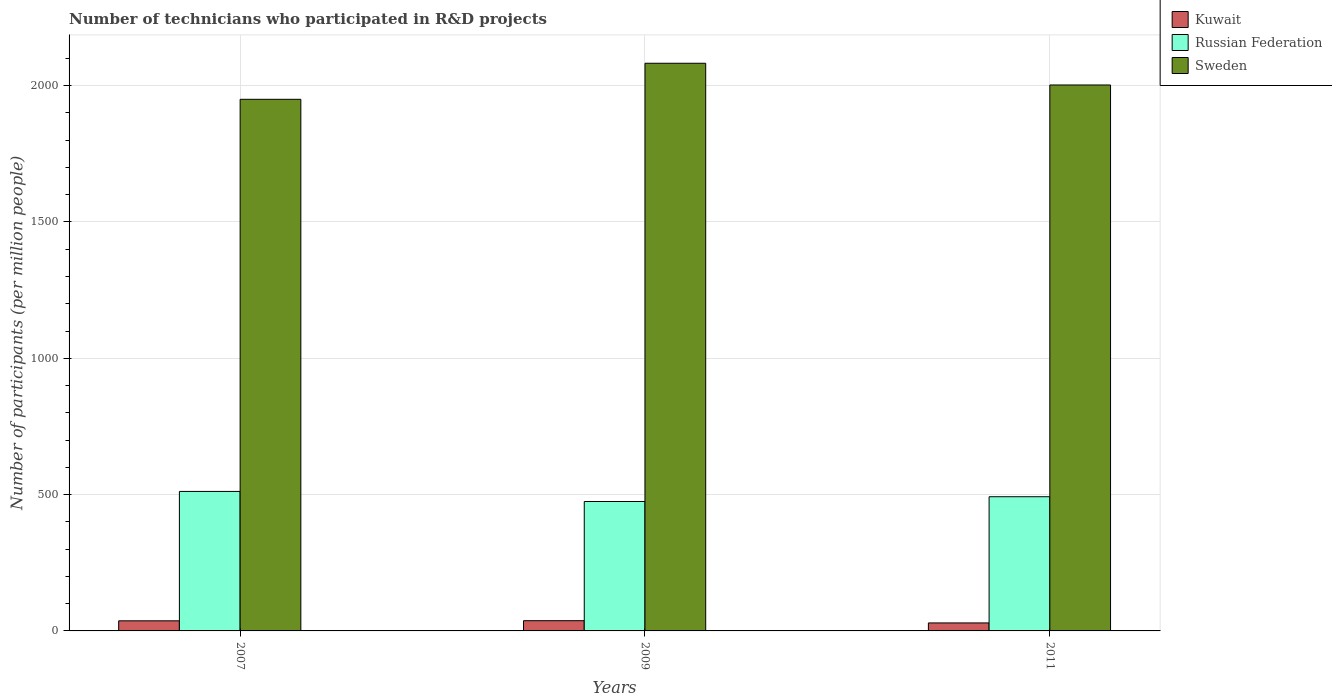How many different coloured bars are there?
Keep it short and to the point. 3. How many groups of bars are there?
Provide a succinct answer. 3. Are the number of bars per tick equal to the number of legend labels?
Ensure brevity in your answer.  Yes. Are the number of bars on each tick of the X-axis equal?
Offer a terse response. Yes. How many bars are there on the 1st tick from the right?
Give a very brief answer. 3. What is the label of the 1st group of bars from the left?
Offer a terse response. 2007. In how many cases, is the number of bars for a given year not equal to the number of legend labels?
Give a very brief answer. 0. What is the number of technicians who participated in R&D projects in Russian Federation in 2007?
Offer a very short reply. 511.64. Across all years, what is the maximum number of technicians who participated in R&D projects in Russian Federation?
Your answer should be very brief. 511.64. Across all years, what is the minimum number of technicians who participated in R&D projects in Kuwait?
Offer a very short reply. 29.33. In which year was the number of technicians who participated in R&D projects in Kuwait maximum?
Offer a terse response. 2009. In which year was the number of technicians who participated in R&D projects in Russian Federation minimum?
Provide a succinct answer. 2009. What is the total number of technicians who participated in R&D projects in Sweden in the graph?
Your answer should be compact. 6034.81. What is the difference between the number of technicians who participated in R&D projects in Kuwait in 2007 and that in 2011?
Offer a very short reply. 7.7. What is the difference between the number of technicians who participated in R&D projects in Russian Federation in 2007 and the number of technicians who participated in R&D projects in Sweden in 2011?
Ensure brevity in your answer.  -1490.93. What is the average number of technicians who participated in R&D projects in Sweden per year?
Your answer should be very brief. 2011.6. In the year 2011, what is the difference between the number of technicians who participated in R&D projects in Russian Federation and number of technicians who participated in R&D projects in Kuwait?
Your answer should be very brief. 462.89. In how many years, is the number of technicians who participated in R&D projects in Russian Federation greater than 1300?
Your response must be concise. 0. What is the ratio of the number of technicians who participated in R&D projects in Sweden in 2007 to that in 2009?
Provide a succinct answer. 0.94. Is the number of technicians who participated in R&D projects in Sweden in 2007 less than that in 2009?
Your answer should be very brief. Yes. What is the difference between the highest and the second highest number of technicians who participated in R&D projects in Sweden?
Your answer should be compact. 79.67. What is the difference between the highest and the lowest number of technicians who participated in R&D projects in Russian Federation?
Provide a short and direct response. 36.87. In how many years, is the number of technicians who participated in R&D projects in Sweden greater than the average number of technicians who participated in R&D projects in Sweden taken over all years?
Provide a succinct answer. 1. Is the sum of the number of technicians who participated in R&D projects in Sweden in 2007 and 2011 greater than the maximum number of technicians who participated in R&D projects in Russian Federation across all years?
Provide a succinct answer. Yes. What does the 3rd bar from the left in 2009 represents?
Offer a very short reply. Sweden. What does the 2nd bar from the right in 2009 represents?
Provide a succinct answer. Russian Federation. Are all the bars in the graph horizontal?
Keep it short and to the point. No. How many years are there in the graph?
Ensure brevity in your answer.  3. Where does the legend appear in the graph?
Offer a terse response. Top right. How are the legend labels stacked?
Provide a succinct answer. Vertical. What is the title of the graph?
Provide a succinct answer. Number of technicians who participated in R&D projects. What is the label or title of the Y-axis?
Offer a very short reply. Number of participants (per million people). What is the Number of participants (per million people) of Kuwait in 2007?
Make the answer very short. 37.03. What is the Number of participants (per million people) in Russian Federation in 2007?
Offer a very short reply. 511.64. What is the Number of participants (per million people) in Sweden in 2007?
Provide a short and direct response. 1950. What is the Number of participants (per million people) in Kuwait in 2009?
Your answer should be compact. 37.48. What is the Number of participants (per million people) in Russian Federation in 2009?
Keep it short and to the point. 474.78. What is the Number of participants (per million people) of Sweden in 2009?
Offer a terse response. 2082.24. What is the Number of participants (per million people) of Kuwait in 2011?
Make the answer very short. 29.33. What is the Number of participants (per million people) in Russian Federation in 2011?
Your answer should be compact. 492.22. What is the Number of participants (per million people) in Sweden in 2011?
Keep it short and to the point. 2002.57. Across all years, what is the maximum Number of participants (per million people) in Kuwait?
Your response must be concise. 37.48. Across all years, what is the maximum Number of participants (per million people) of Russian Federation?
Make the answer very short. 511.64. Across all years, what is the maximum Number of participants (per million people) in Sweden?
Ensure brevity in your answer.  2082.24. Across all years, what is the minimum Number of participants (per million people) of Kuwait?
Your answer should be compact. 29.33. Across all years, what is the minimum Number of participants (per million people) in Russian Federation?
Your response must be concise. 474.78. Across all years, what is the minimum Number of participants (per million people) in Sweden?
Provide a succinct answer. 1950. What is the total Number of participants (per million people) in Kuwait in the graph?
Your answer should be very brief. 103.84. What is the total Number of participants (per million people) of Russian Federation in the graph?
Ensure brevity in your answer.  1478.63. What is the total Number of participants (per million people) of Sweden in the graph?
Provide a succinct answer. 6034.81. What is the difference between the Number of participants (per million people) of Kuwait in 2007 and that in 2009?
Provide a succinct answer. -0.46. What is the difference between the Number of participants (per million people) of Russian Federation in 2007 and that in 2009?
Ensure brevity in your answer.  36.87. What is the difference between the Number of participants (per million people) of Sweden in 2007 and that in 2009?
Make the answer very short. -132.24. What is the difference between the Number of participants (per million people) of Kuwait in 2007 and that in 2011?
Your answer should be very brief. 7.7. What is the difference between the Number of participants (per million people) of Russian Federation in 2007 and that in 2011?
Your answer should be compact. 19.43. What is the difference between the Number of participants (per million people) in Sweden in 2007 and that in 2011?
Your answer should be compact. -52.56. What is the difference between the Number of participants (per million people) of Kuwait in 2009 and that in 2011?
Make the answer very short. 8.16. What is the difference between the Number of participants (per million people) in Russian Federation in 2009 and that in 2011?
Your response must be concise. -17.44. What is the difference between the Number of participants (per million people) in Sweden in 2009 and that in 2011?
Keep it short and to the point. 79.67. What is the difference between the Number of participants (per million people) in Kuwait in 2007 and the Number of participants (per million people) in Russian Federation in 2009?
Offer a terse response. -437.75. What is the difference between the Number of participants (per million people) in Kuwait in 2007 and the Number of participants (per million people) in Sweden in 2009?
Ensure brevity in your answer.  -2045.21. What is the difference between the Number of participants (per million people) of Russian Federation in 2007 and the Number of participants (per million people) of Sweden in 2009?
Provide a succinct answer. -1570.6. What is the difference between the Number of participants (per million people) in Kuwait in 2007 and the Number of participants (per million people) in Russian Federation in 2011?
Offer a terse response. -455.19. What is the difference between the Number of participants (per million people) in Kuwait in 2007 and the Number of participants (per million people) in Sweden in 2011?
Provide a succinct answer. -1965.54. What is the difference between the Number of participants (per million people) of Russian Federation in 2007 and the Number of participants (per million people) of Sweden in 2011?
Your answer should be very brief. -1490.93. What is the difference between the Number of participants (per million people) in Kuwait in 2009 and the Number of participants (per million people) in Russian Federation in 2011?
Your answer should be very brief. -454.73. What is the difference between the Number of participants (per million people) in Kuwait in 2009 and the Number of participants (per million people) in Sweden in 2011?
Offer a very short reply. -1965.08. What is the difference between the Number of participants (per million people) of Russian Federation in 2009 and the Number of participants (per million people) of Sweden in 2011?
Offer a very short reply. -1527.79. What is the average Number of participants (per million people) of Kuwait per year?
Give a very brief answer. 34.61. What is the average Number of participants (per million people) in Russian Federation per year?
Provide a short and direct response. 492.88. What is the average Number of participants (per million people) of Sweden per year?
Your answer should be very brief. 2011.6. In the year 2007, what is the difference between the Number of participants (per million people) in Kuwait and Number of participants (per million people) in Russian Federation?
Provide a succinct answer. -474.61. In the year 2007, what is the difference between the Number of participants (per million people) of Kuwait and Number of participants (per million people) of Sweden?
Make the answer very short. -1912.98. In the year 2007, what is the difference between the Number of participants (per million people) in Russian Federation and Number of participants (per million people) in Sweden?
Your answer should be very brief. -1438.36. In the year 2009, what is the difference between the Number of participants (per million people) of Kuwait and Number of participants (per million people) of Russian Federation?
Your response must be concise. -437.29. In the year 2009, what is the difference between the Number of participants (per million people) of Kuwait and Number of participants (per million people) of Sweden?
Your answer should be compact. -2044.76. In the year 2009, what is the difference between the Number of participants (per million people) in Russian Federation and Number of participants (per million people) in Sweden?
Offer a very short reply. -1607.47. In the year 2011, what is the difference between the Number of participants (per million people) of Kuwait and Number of participants (per million people) of Russian Federation?
Make the answer very short. -462.89. In the year 2011, what is the difference between the Number of participants (per million people) of Kuwait and Number of participants (per million people) of Sweden?
Give a very brief answer. -1973.24. In the year 2011, what is the difference between the Number of participants (per million people) of Russian Federation and Number of participants (per million people) of Sweden?
Offer a terse response. -1510.35. What is the ratio of the Number of participants (per million people) in Kuwait in 2007 to that in 2009?
Your answer should be compact. 0.99. What is the ratio of the Number of participants (per million people) of Russian Federation in 2007 to that in 2009?
Give a very brief answer. 1.08. What is the ratio of the Number of participants (per million people) of Sweden in 2007 to that in 2009?
Your answer should be compact. 0.94. What is the ratio of the Number of participants (per million people) in Kuwait in 2007 to that in 2011?
Offer a terse response. 1.26. What is the ratio of the Number of participants (per million people) in Russian Federation in 2007 to that in 2011?
Keep it short and to the point. 1.04. What is the ratio of the Number of participants (per million people) of Sweden in 2007 to that in 2011?
Ensure brevity in your answer.  0.97. What is the ratio of the Number of participants (per million people) of Kuwait in 2009 to that in 2011?
Give a very brief answer. 1.28. What is the ratio of the Number of participants (per million people) in Russian Federation in 2009 to that in 2011?
Your answer should be very brief. 0.96. What is the ratio of the Number of participants (per million people) of Sweden in 2009 to that in 2011?
Make the answer very short. 1.04. What is the difference between the highest and the second highest Number of participants (per million people) of Kuwait?
Provide a short and direct response. 0.46. What is the difference between the highest and the second highest Number of participants (per million people) in Russian Federation?
Offer a terse response. 19.43. What is the difference between the highest and the second highest Number of participants (per million people) in Sweden?
Offer a terse response. 79.67. What is the difference between the highest and the lowest Number of participants (per million people) of Kuwait?
Keep it short and to the point. 8.16. What is the difference between the highest and the lowest Number of participants (per million people) in Russian Federation?
Ensure brevity in your answer.  36.87. What is the difference between the highest and the lowest Number of participants (per million people) in Sweden?
Provide a short and direct response. 132.24. 